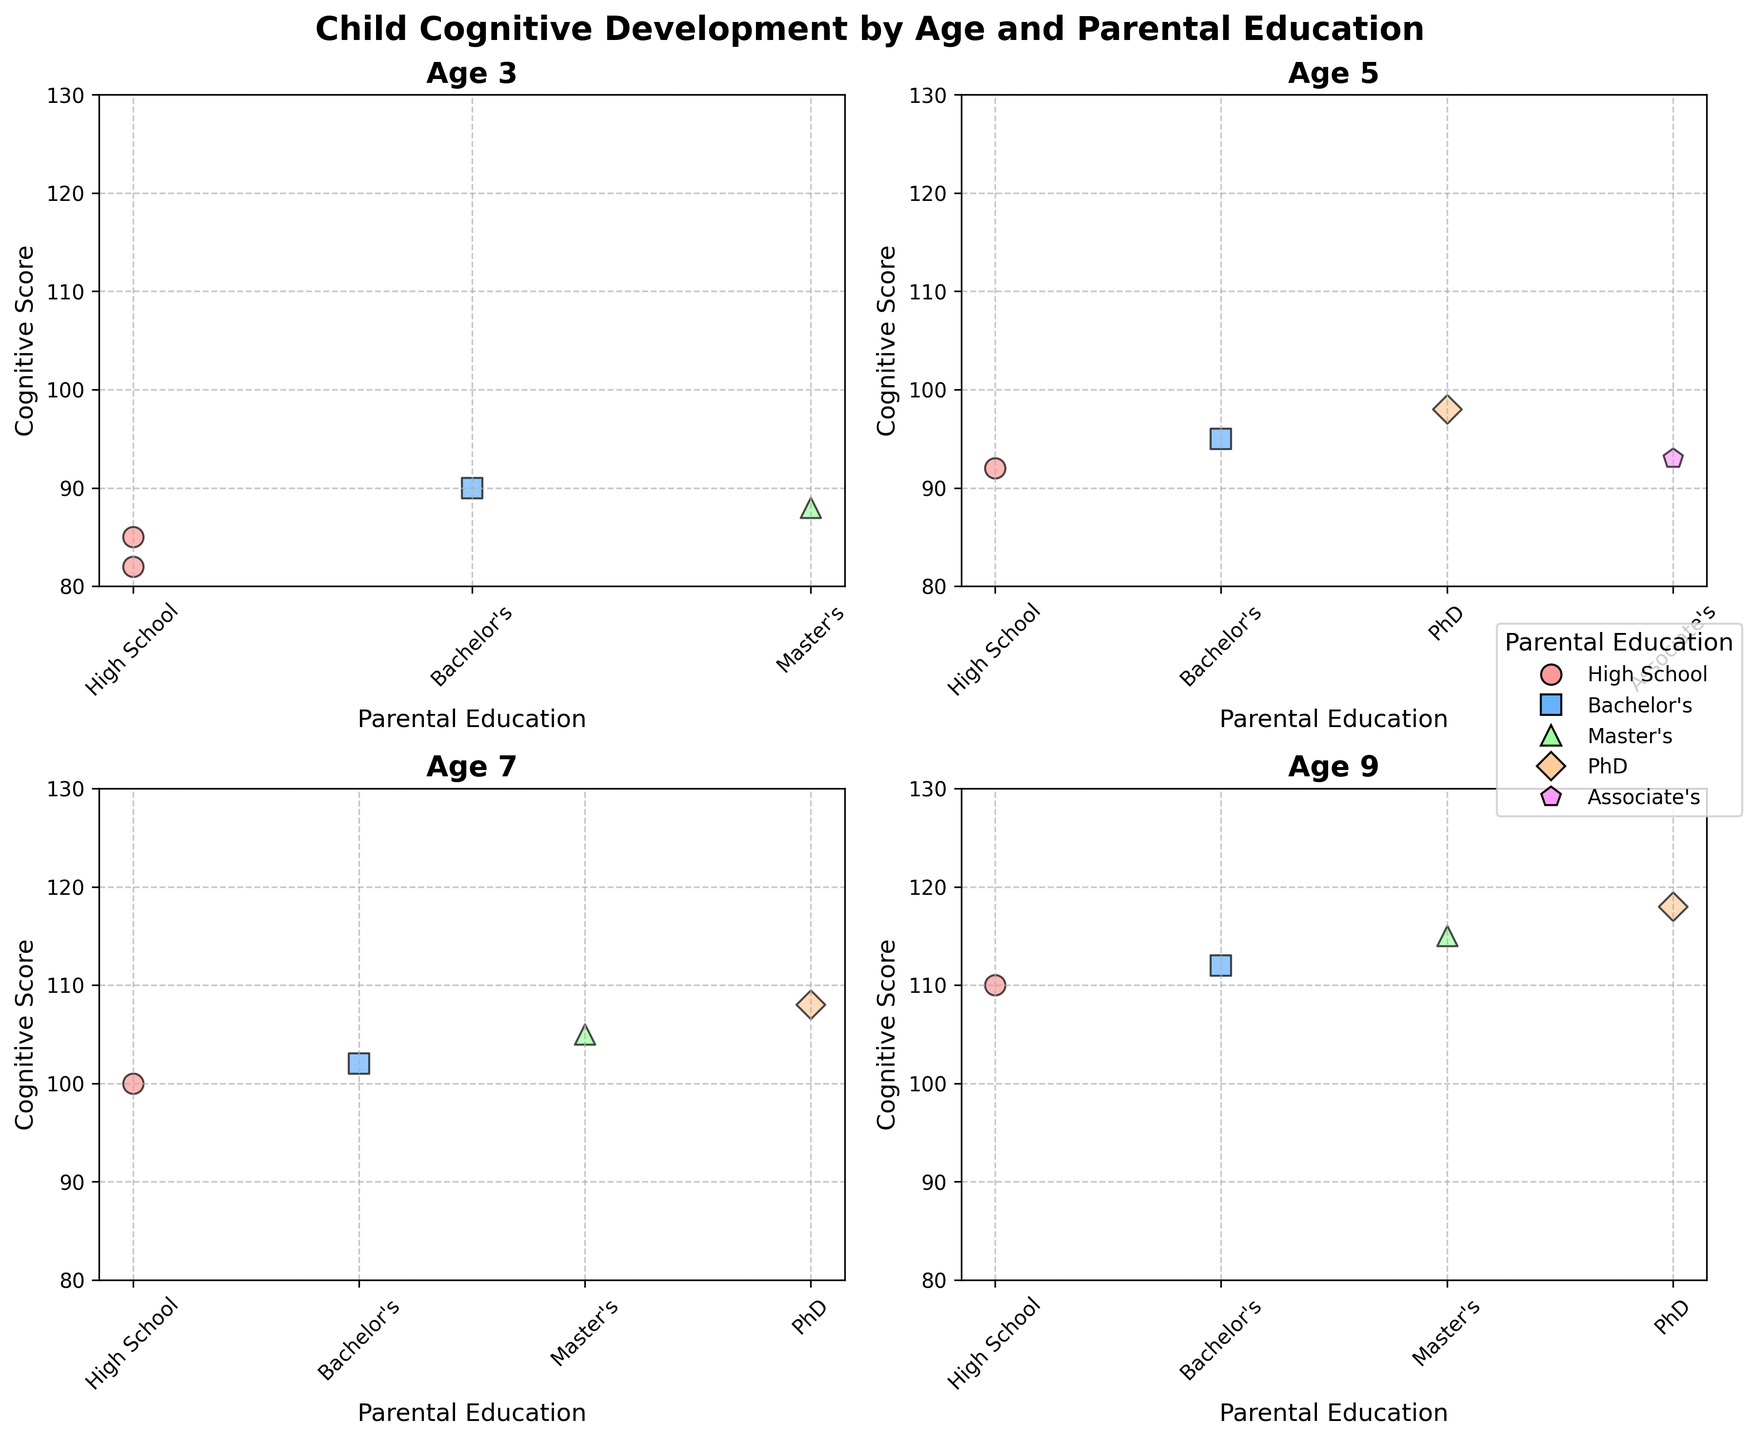What is the title of the figure? The title is located at the top of the figure. It summarizes the content of the figure, referring to child cognitive development across different age groups and parental education levels.
Answer: Child Cognitive Development by Age and Parental Education How many age groups are displayed in the figure? By examining the subplots, we can count the number of unique age groups shown. Each subplot title corresponds to a distinct age group.
Answer: 4 Which parental education level has the highest cognitive score for children aged 5? In the subplot for age 5, observe the points corresponding to different parental education levels and identify the one with the highest cognitive score.
Answer: PhD What is the range of cognitive scores for children aged 7? The range can be found by identifying the minimum and maximum cognitive scores for age 7 in their respective subplot.
Answer: 100-108 Compare the cognitive scores of children aged 9 whose parents have a Master's degree to those whose parents have a PhD. Which group performs better? Locate the points for age 9 in the subplot, then compare the scores for Master's and PhD. Identify which group has higher cognitive scores.
Answer: PhD Are there any parental education levels that appear in all four age group subplots? Check each subplot to see if there is any parental education level that is represented in all four age groups.
Answer: High School Identify the age group with the most varied cognitive scores. Examine the spread of cognitive scores in each subplot. The age group with the widest range from the lowest to the highest score has the most variation.
Answer: 7 What is the average cognitive score for children aged 3 across all parental education levels? Add the cognitive scores for all children aged 3 and divide by the number of data points in that age group. The formula is (85 + 90 + 82 + 88) / 4.
Answer: 86.25 Which marital status has data points only in one subplot? Inspect the marital status labels across all the subplots to see if any status appears in only one subplot.
Answer: Separated in age 5 